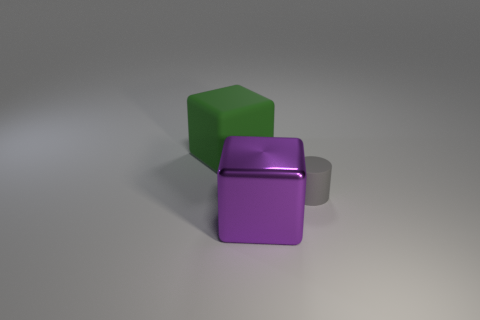What is the lighting situation in this image? The image is lit from above, with the source of light casting soft shadows directly underneath the objects. This indicates a single diffused light source, like an overhead lamp. 